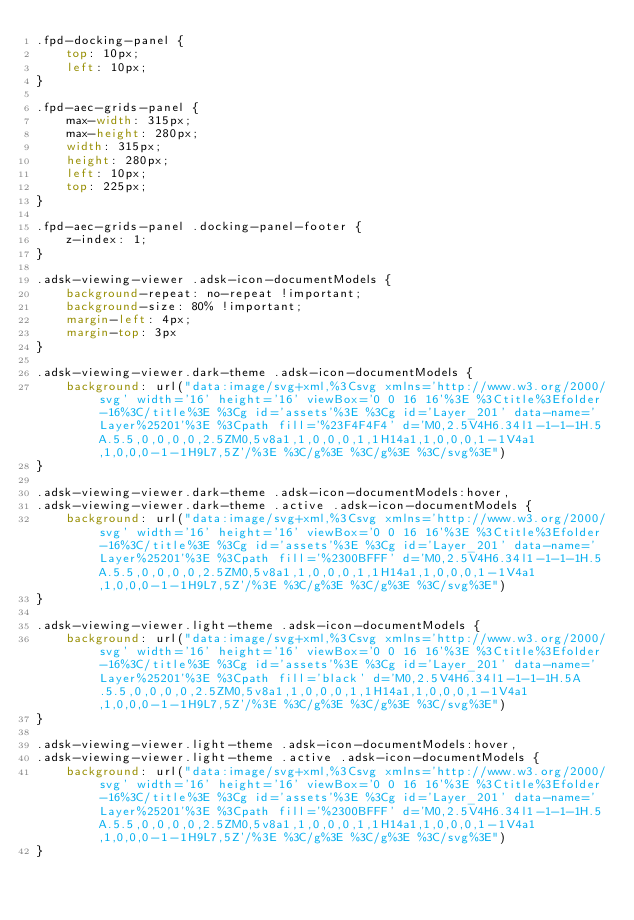Convert code to text. <code><loc_0><loc_0><loc_500><loc_500><_CSS_>.fpd-docking-panel {
    top: 10px;
    left: 10px;
}

.fpd-aec-grids-panel {
    max-width: 315px;
    max-height: 280px;
    width: 315px;
    height: 280px;
    left: 10px;
    top: 225px;
}

.fpd-aec-grids-panel .docking-panel-footer {
    z-index: 1;
}

.adsk-viewing-viewer .adsk-icon-documentModels {
    background-repeat: no-repeat !important;
    background-size: 80% !important;
    margin-left: 4px;
    margin-top: 3px
}

.adsk-viewing-viewer.dark-theme .adsk-icon-documentModels {
    background: url("data:image/svg+xml,%3Csvg xmlns='http://www.w3.org/2000/svg' width='16' height='16' viewBox='0 0 16 16'%3E %3Ctitle%3Efolder-16%3C/title%3E %3Cg id='assets'%3E %3Cg id='Layer_201' data-name='Layer%25201'%3E %3Cpath fill='%23F4F4F4' d='M0,2.5V4H6.34l1-1-1-1H.5A.5.5,0,0,0,0,2.5ZM0,5v8a1,1,0,0,0,1,1H14a1,1,0,0,0,1-1V4a1,1,0,0,0-1-1H9L7,5Z'/%3E %3C/g%3E %3C/g%3E %3C/svg%3E")
}

.adsk-viewing-viewer.dark-theme .adsk-icon-documentModels:hover,
.adsk-viewing-viewer.dark-theme .active .adsk-icon-documentModels {
    background: url("data:image/svg+xml,%3Csvg xmlns='http://www.w3.org/2000/svg' width='16' height='16' viewBox='0 0 16 16'%3E %3Ctitle%3Efolder-16%3C/title%3E %3Cg id='assets'%3E %3Cg id='Layer_201' data-name='Layer%25201'%3E %3Cpath fill='%2300BFFF' d='M0,2.5V4H6.34l1-1-1-1H.5A.5.5,0,0,0,0,2.5ZM0,5v8a1,1,0,0,0,1,1H14a1,1,0,0,0,1-1V4a1,1,0,0,0-1-1H9L7,5Z'/%3E %3C/g%3E %3C/g%3E %3C/svg%3E")
}

.adsk-viewing-viewer.light-theme .adsk-icon-documentModels {
    background: url("data:image/svg+xml,%3Csvg xmlns='http://www.w3.org/2000/svg' width='16' height='16' viewBox='0 0 16 16'%3E %3Ctitle%3Efolder-16%3C/title%3E %3Cg id='assets'%3E %3Cg id='Layer_201' data-name='Layer%25201'%3E %3Cpath fill='black' d='M0,2.5V4H6.34l1-1-1-1H.5A.5.5,0,0,0,0,2.5ZM0,5v8a1,1,0,0,0,1,1H14a1,1,0,0,0,1-1V4a1,1,0,0,0-1-1H9L7,5Z'/%3E %3C/g%3E %3C/g%3E %3C/svg%3E")
}

.adsk-viewing-viewer.light-theme .adsk-icon-documentModels:hover,
.adsk-viewing-viewer.light-theme .active .adsk-icon-documentModels {
    background: url("data:image/svg+xml,%3Csvg xmlns='http://www.w3.org/2000/svg' width='16' height='16' viewBox='0 0 16 16'%3E %3Ctitle%3Efolder-16%3C/title%3E %3Cg id='assets'%3E %3Cg id='Layer_201' data-name='Layer%25201'%3E %3Cpath fill='%2300BFFF' d='M0,2.5V4H6.34l1-1-1-1H.5A.5.5,0,0,0,0,2.5ZM0,5v8a1,1,0,0,0,1,1H14a1,1,0,0,0,1-1V4a1,1,0,0,0-1-1H9L7,5Z'/%3E %3C/g%3E %3C/g%3E %3C/svg%3E")
}</code> 